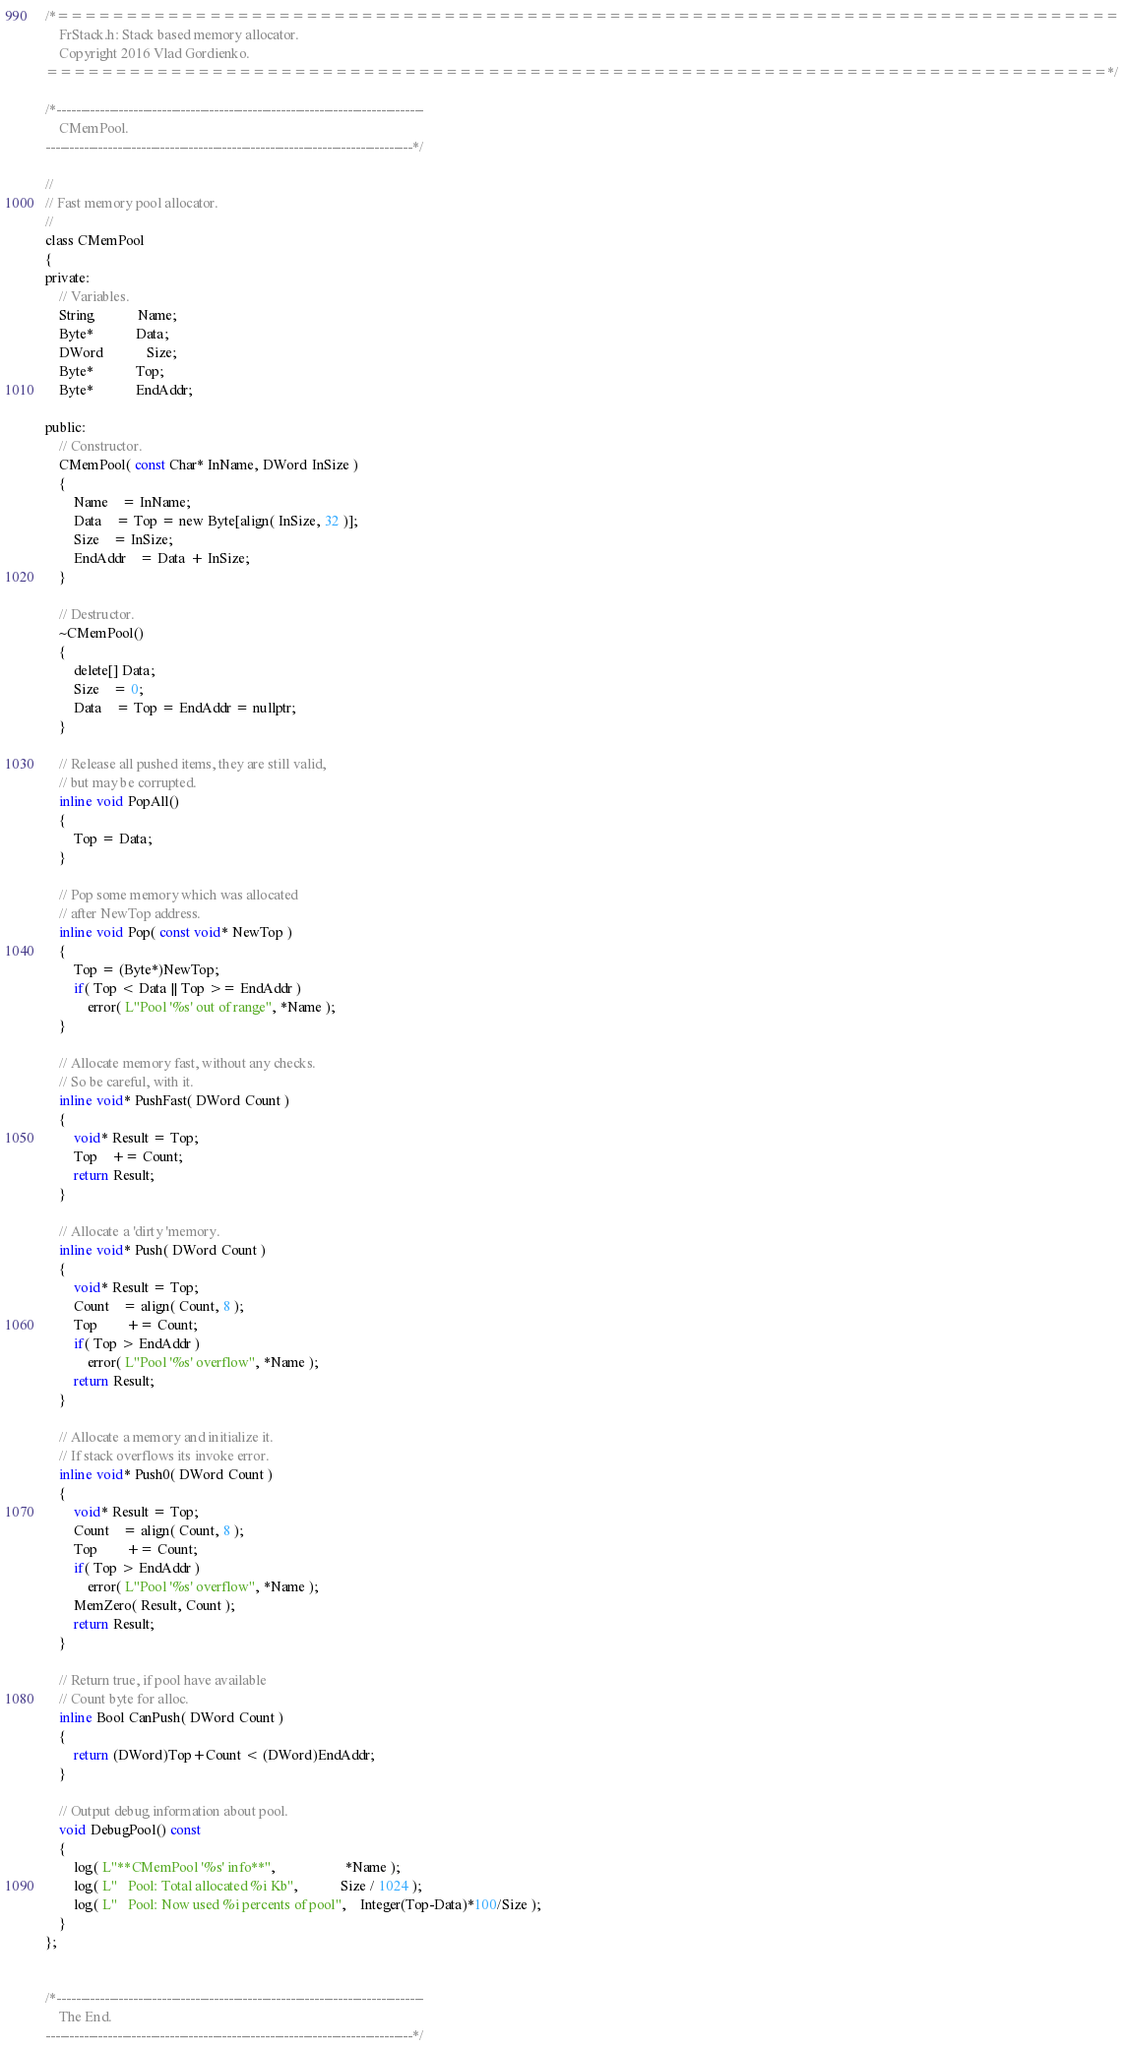<code> <loc_0><loc_0><loc_500><loc_500><_C_>/*=============================================================================
    FrStack.h: Stack based memory allocator.
    Copyright 2016 Vlad Gordienko.
=============================================================================*/

/*-----------------------------------------------------------------------------
    CMemPool.
-----------------------------------------------------------------------------*/

//
// Fast memory pool allocator.
//
class CMemPool
{
private:
	// Variables.
	String			Name;
	Byte*			Data;
	DWord			Size;
	Byte*			Top;
	Byte*			EndAddr;

public:
	// Constructor.
	CMemPool( const Char* InName, DWord InSize )
	{
		Name	= InName;
		Data	= Top = new Byte[align( InSize, 32 )];
		Size	= InSize;
		EndAddr	= Data + InSize;
	}

	// Destructor.
	~CMemPool()
	{
		delete[] Data;
		Size	= 0;
		Data	= Top = EndAddr = nullptr;
	}

	// Release all pushed items, they are still valid,
	// but may be corrupted.
	inline void PopAll()
	{
		Top = Data;
	}

	// Pop some memory which was allocated
	// after NewTop address.
	inline void Pop( const void* NewTop )
	{
		Top = (Byte*)NewTop;
		if( Top < Data || Top >= EndAddr )
			error( L"Pool '%s' out of range", *Name );
	}

	// Allocate memory fast, without any checks.
	// So be careful, with it.
	inline void* PushFast( DWord Count )
	{
		void* Result = Top;
		Top	+= Count;
		return Result;
	}

	// Allocate a 'dirty 'memory. 
	inline void* Push( DWord Count )
	{
		void* Result = Top;
		Count	= align( Count, 8 );
		Top		+= Count;
		if( Top > EndAddr )
			error( L"Pool '%s' overflow", *Name );
		return Result;
	}

	// Allocate a memory and initialize it.
	// If stack overflows its invoke error.
	inline void* Push0( DWord Count )
	{
		void* Result = Top;
		Count	= align( Count, 8 );
		Top		+= Count;
		if( Top > EndAddr )
			error( L"Pool '%s' overflow", *Name );
		MemZero( Result, Count );
		return Result;
	}

	// Return true, if pool have available
	// Count byte for alloc.
	inline Bool CanPush( DWord Count )
	{
		return (DWord)Top+Count < (DWord)EndAddr;
	}

	// Output debug information about pool.
	void DebugPool() const
	{
		log( L"**CMemPool '%s' info**",					*Name );
		log( L"   Pool: Total allocated %i Kb",			Size / 1024 );
		log( L"   Pool: Now used %i percents of pool",	Integer(Top-Data)*100/Size );
	}
};


/*-----------------------------------------------------------------------------
    The End.
-----------------------------------------------------------------------------*/</code> 